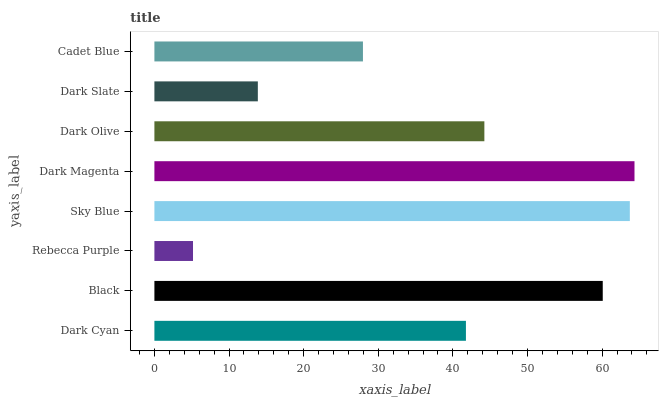Is Rebecca Purple the minimum?
Answer yes or no. Yes. Is Dark Magenta the maximum?
Answer yes or no. Yes. Is Black the minimum?
Answer yes or no. No. Is Black the maximum?
Answer yes or no. No. Is Black greater than Dark Cyan?
Answer yes or no. Yes. Is Dark Cyan less than Black?
Answer yes or no. Yes. Is Dark Cyan greater than Black?
Answer yes or no. No. Is Black less than Dark Cyan?
Answer yes or no. No. Is Dark Olive the high median?
Answer yes or no. Yes. Is Dark Cyan the low median?
Answer yes or no. Yes. Is Rebecca Purple the high median?
Answer yes or no. No. Is Black the low median?
Answer yes or no. No. 